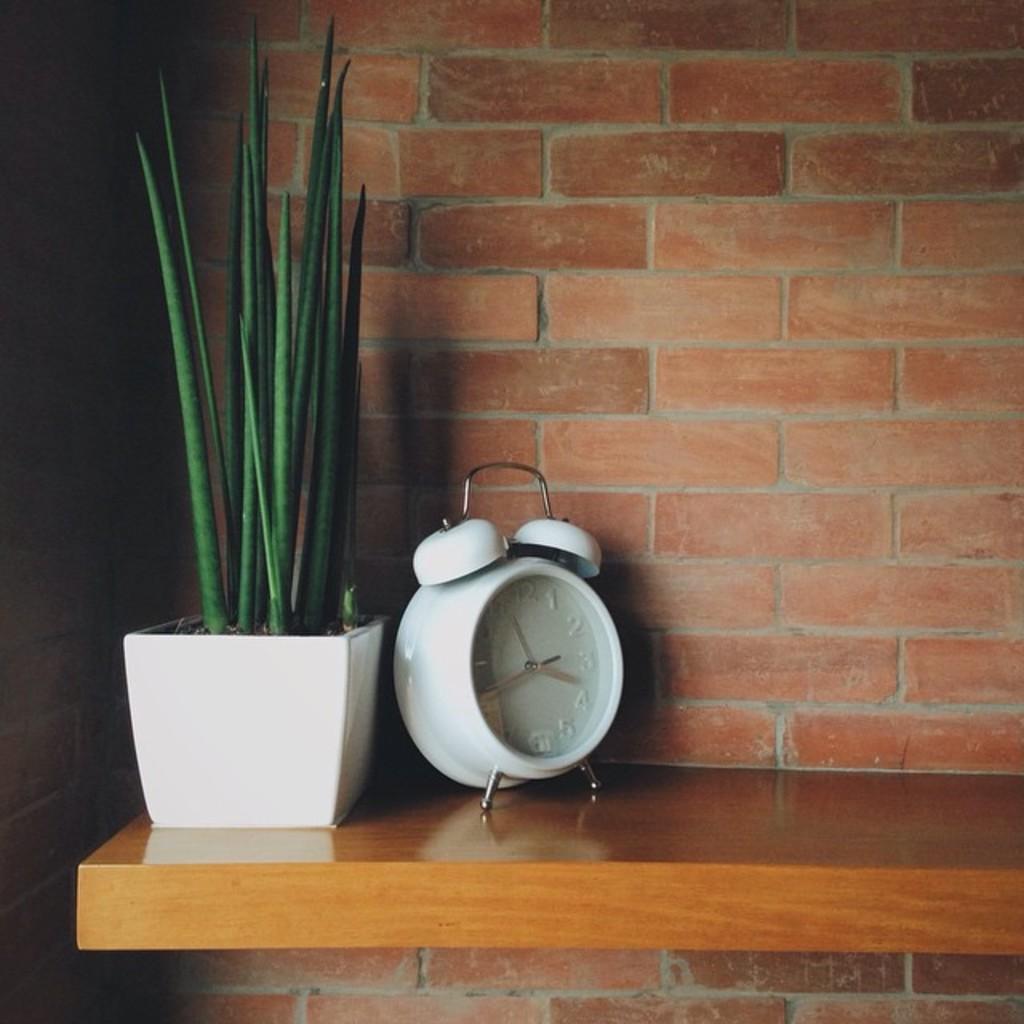In one or two sentences, can you explain what this image depicts? In this image there is a small plant pot on the wooden desk. Beside the plant there is a clock. In the background there is a wall. 